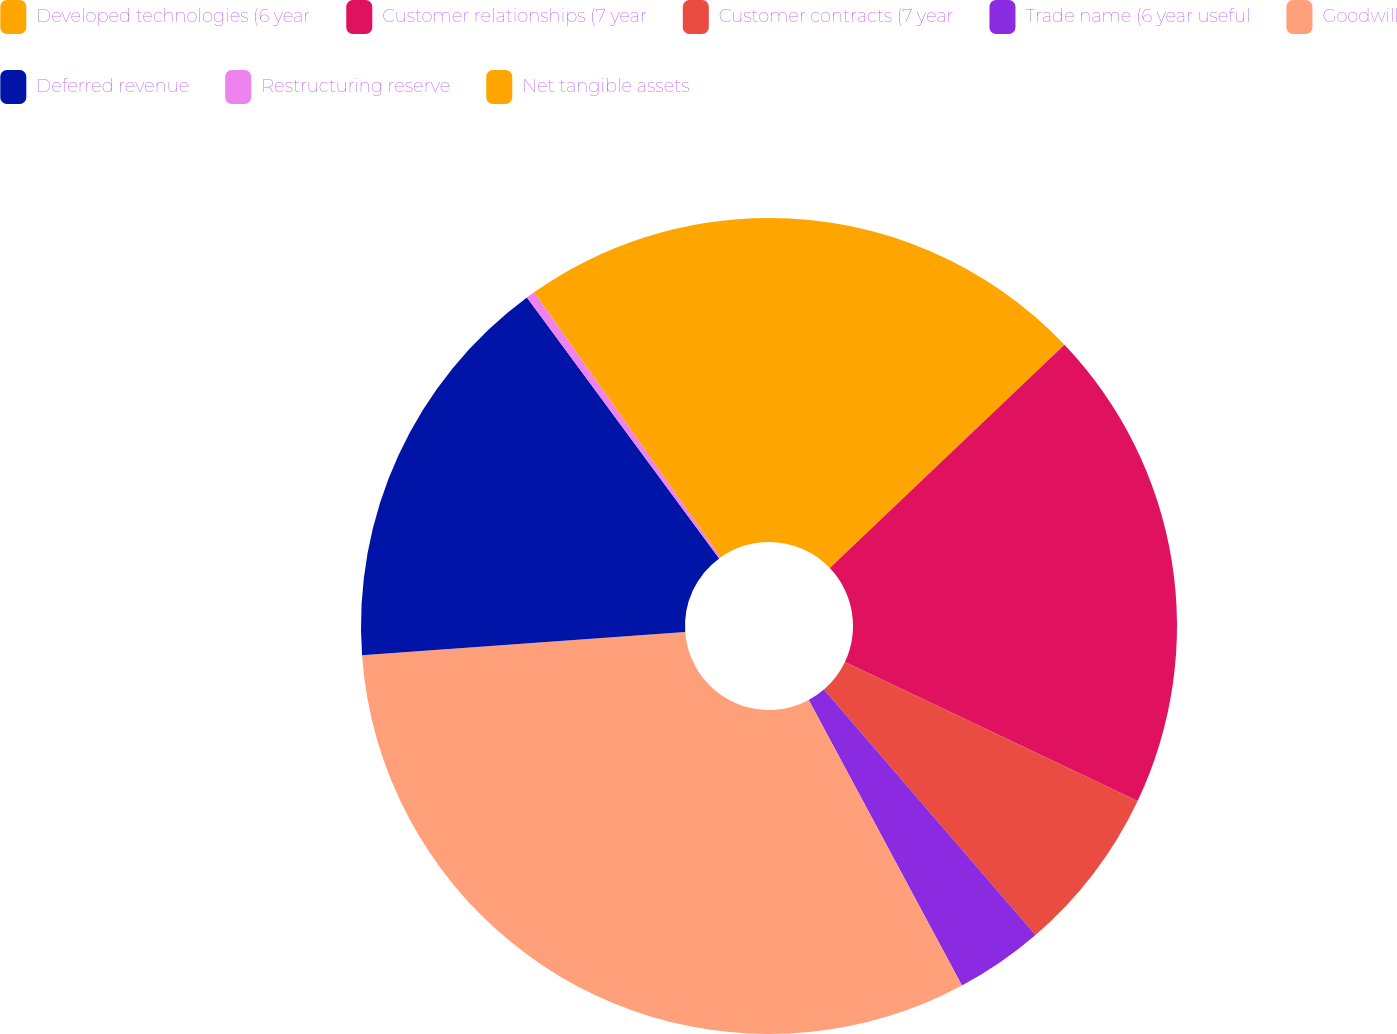Convert chart to OTSL. <chart><loc_0><loc_0><loc_500><loc_500><pie_chart><fcel>Developed technologies (6 year<fcel>Customer relationships (7 year<fcel>Customer contracts (7 year<fcel>Trade name (6 year useful<fcel>Goodwill<fcel>Deferred revenue<fcel>Restructuring reserve<fcel>Net tangible assets<nl><fcel>12.89%<fcel>19.16%<fcel>6.62%<fcel>3.49%<fcel>31.7%<fcel>16.03%<fcel>0.35%<fcel>9.76%<nl></chart> 